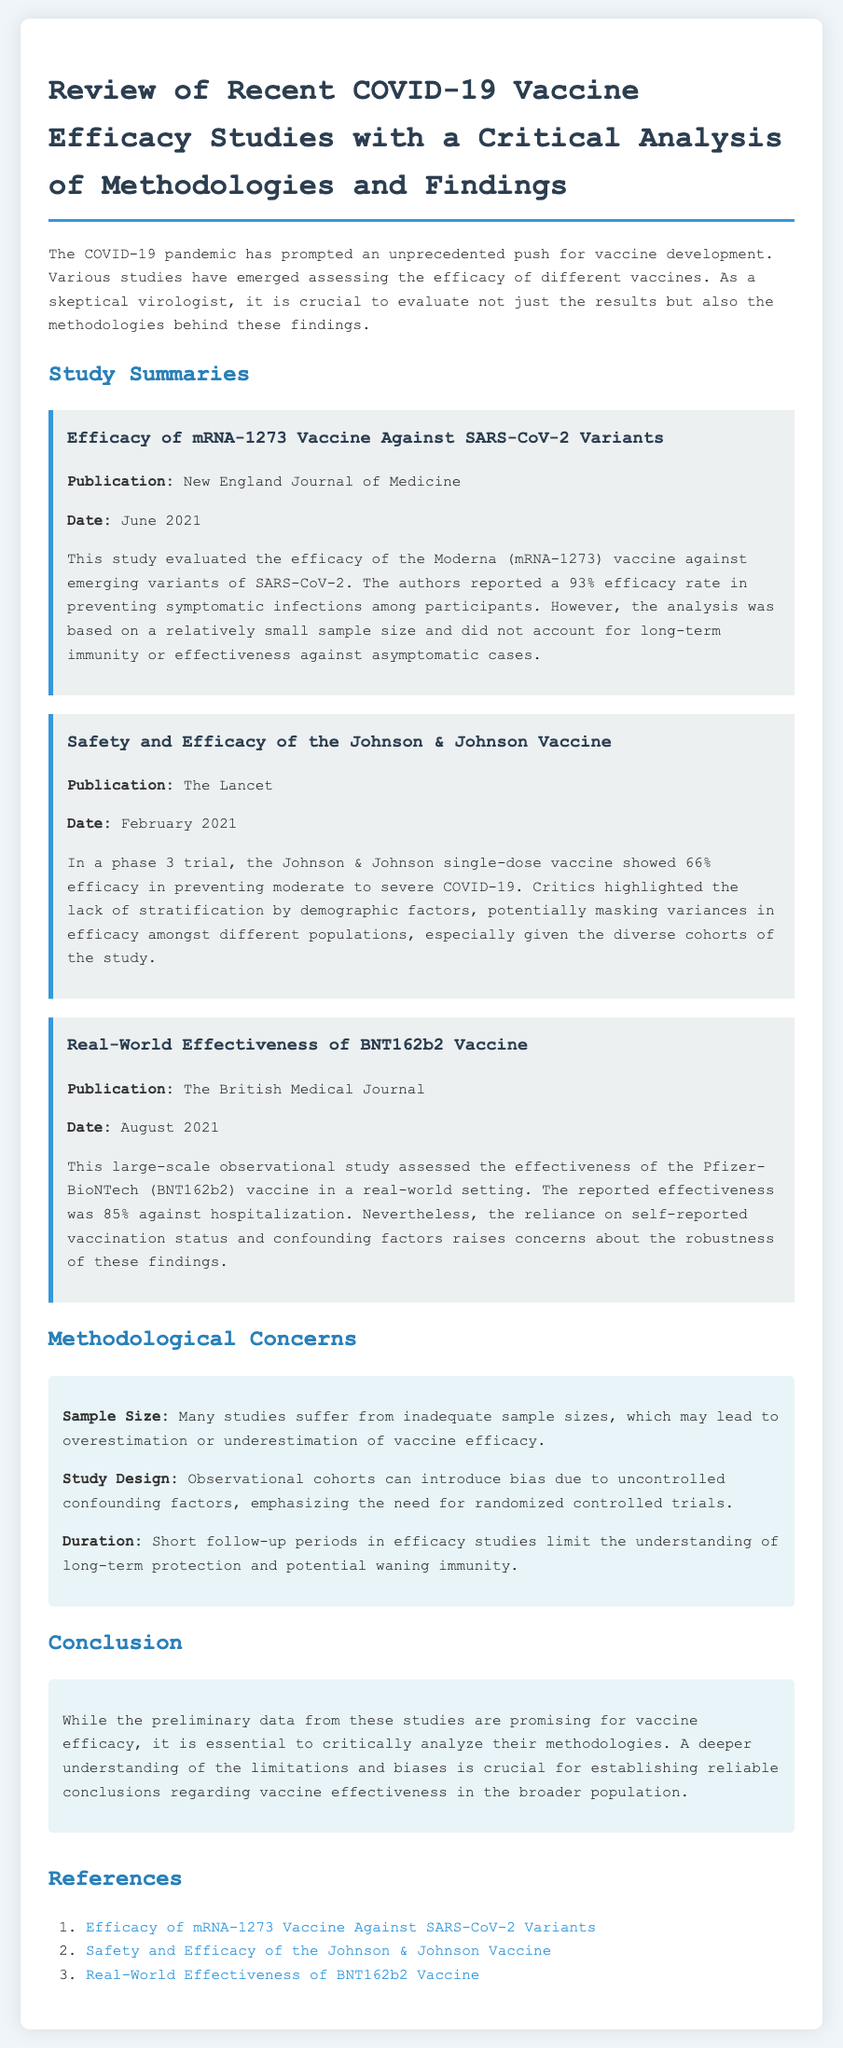What is the title of the document? The title is explicitly stated in the document header and is essential for identifying the topic of the content.
Answer: Review of Recent COVID-19 Vaccine Efficacy Studies with a Critical Analysis of Methodologies and Findings What is the efficacy rate reported for the mRNA-1273 vaccine? The efficacy rate is a specific numerical result mentioned in the study summary of the document.
Answer: 93% Who published the study on the Johnson & Johnson vaccine? The publisher is noted in the study summary, indicating the source of the research findings.
Answer: The Lancet When was the real-world effectiveness study of the BNT162b2 vaccine published? The date is included in the summary to provide context for the study's relevance.
Answer: August 2021 What methodological concern is raised regarding sample size? This concern is explicitly identified in the section dedicated to methodological issues in the document.
Answer: Inadequate sample sizes Which vaccine is associated with a 66% efficacy rate? The efficacy rate is tied to a specific vaccine detailed in the document, allowing for easy identification.
Answer: Johnson & Johnson What kind of trial did the Johnson & Johnson vaccine undergo? The type of trial is specified in the study, indicating the nature of the research conducted.
Answer: Phase 3 trial What is mentioned as a limitation of observational studies? The document states specific biases related to observational cohorts, relevant for understanding study validity.
Answer: Uncontrolled confounding factors What is the reported effectiveness of the Pfizer-BioNTech vaccine against hospitalization? The effectiveness figure is provided to summarize the findings in the context of the study assessments.
Answer: 85% 